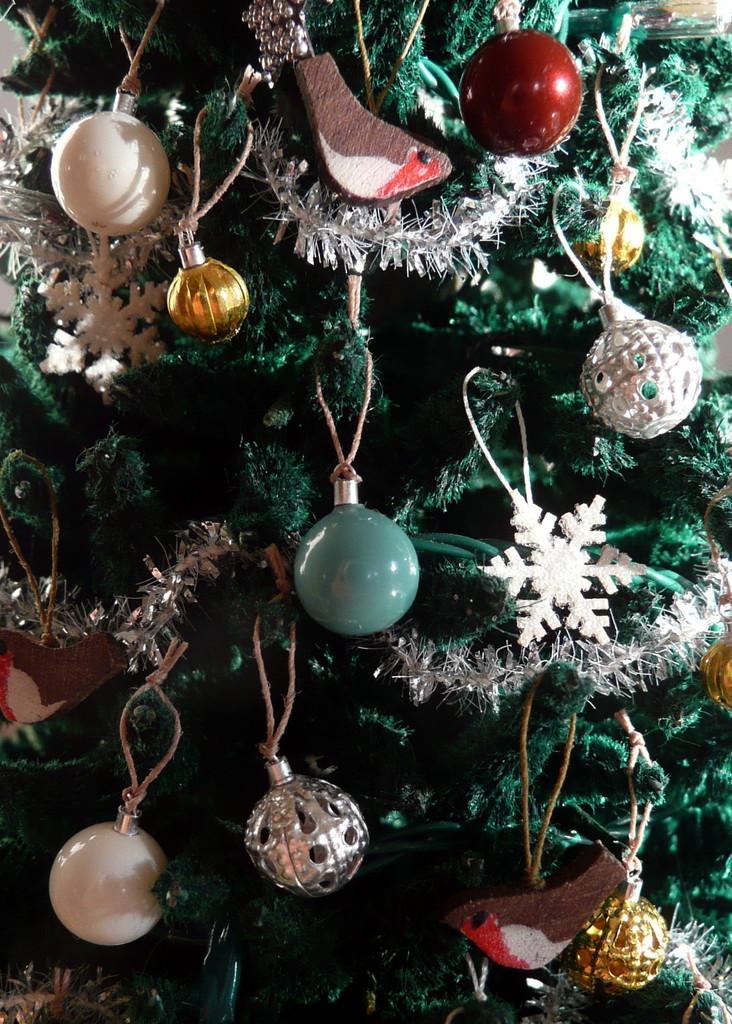How would you summarize this image in a sentence or two? In this picture I can see few decorative balls to the christmas tree. 